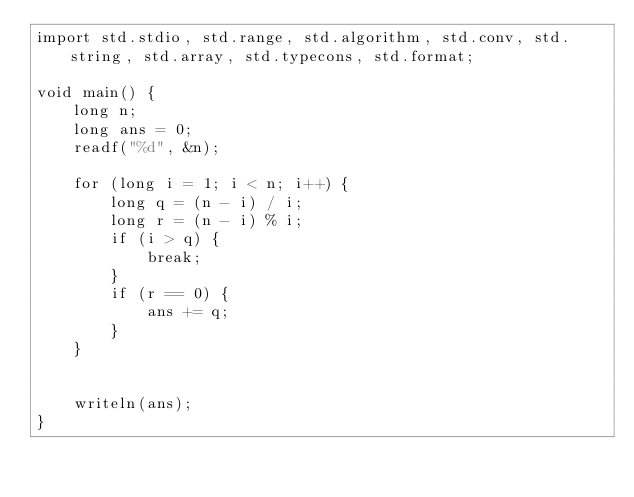<code> <loc_0><loc_0><loc_500><loc_500><_D_>import std.stdio, std.range, std.algorithm, std.conv, std.string, std.array, std.typecons, std.format;

void main() {
    long n;
    long ans = 0;
    readf("%d", &n);

    for (long i = 1; i < n; i++) {
        long q = (n - i) / i;
        long r = (n - i) % i;
        if (i > q) {
            break;
        }
        if (r == 0) {
            ans += q;
        }
    }


    writeln(ans);
}

</code> 